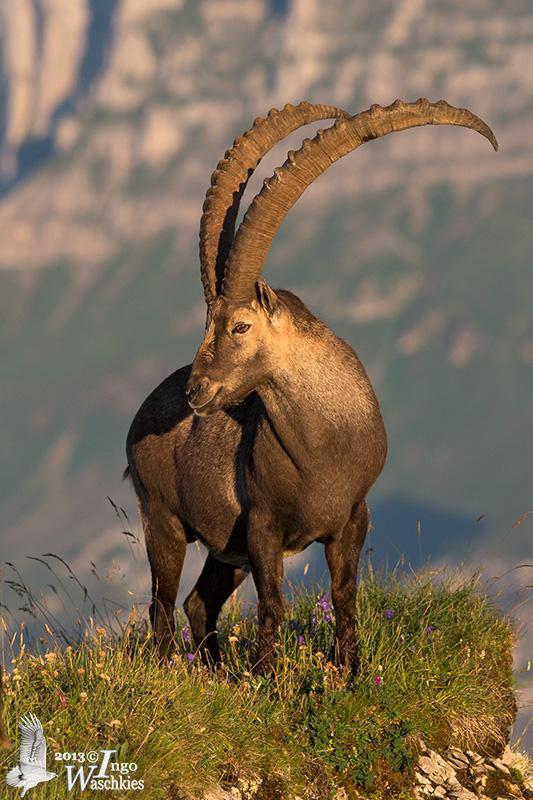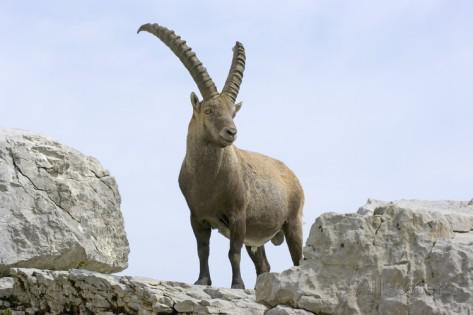The first image is the image on the left, the second image is the image on the right. For the images displayed, is the sentence "There is a total of four animals." factually correct? Answer yes or no. No. 